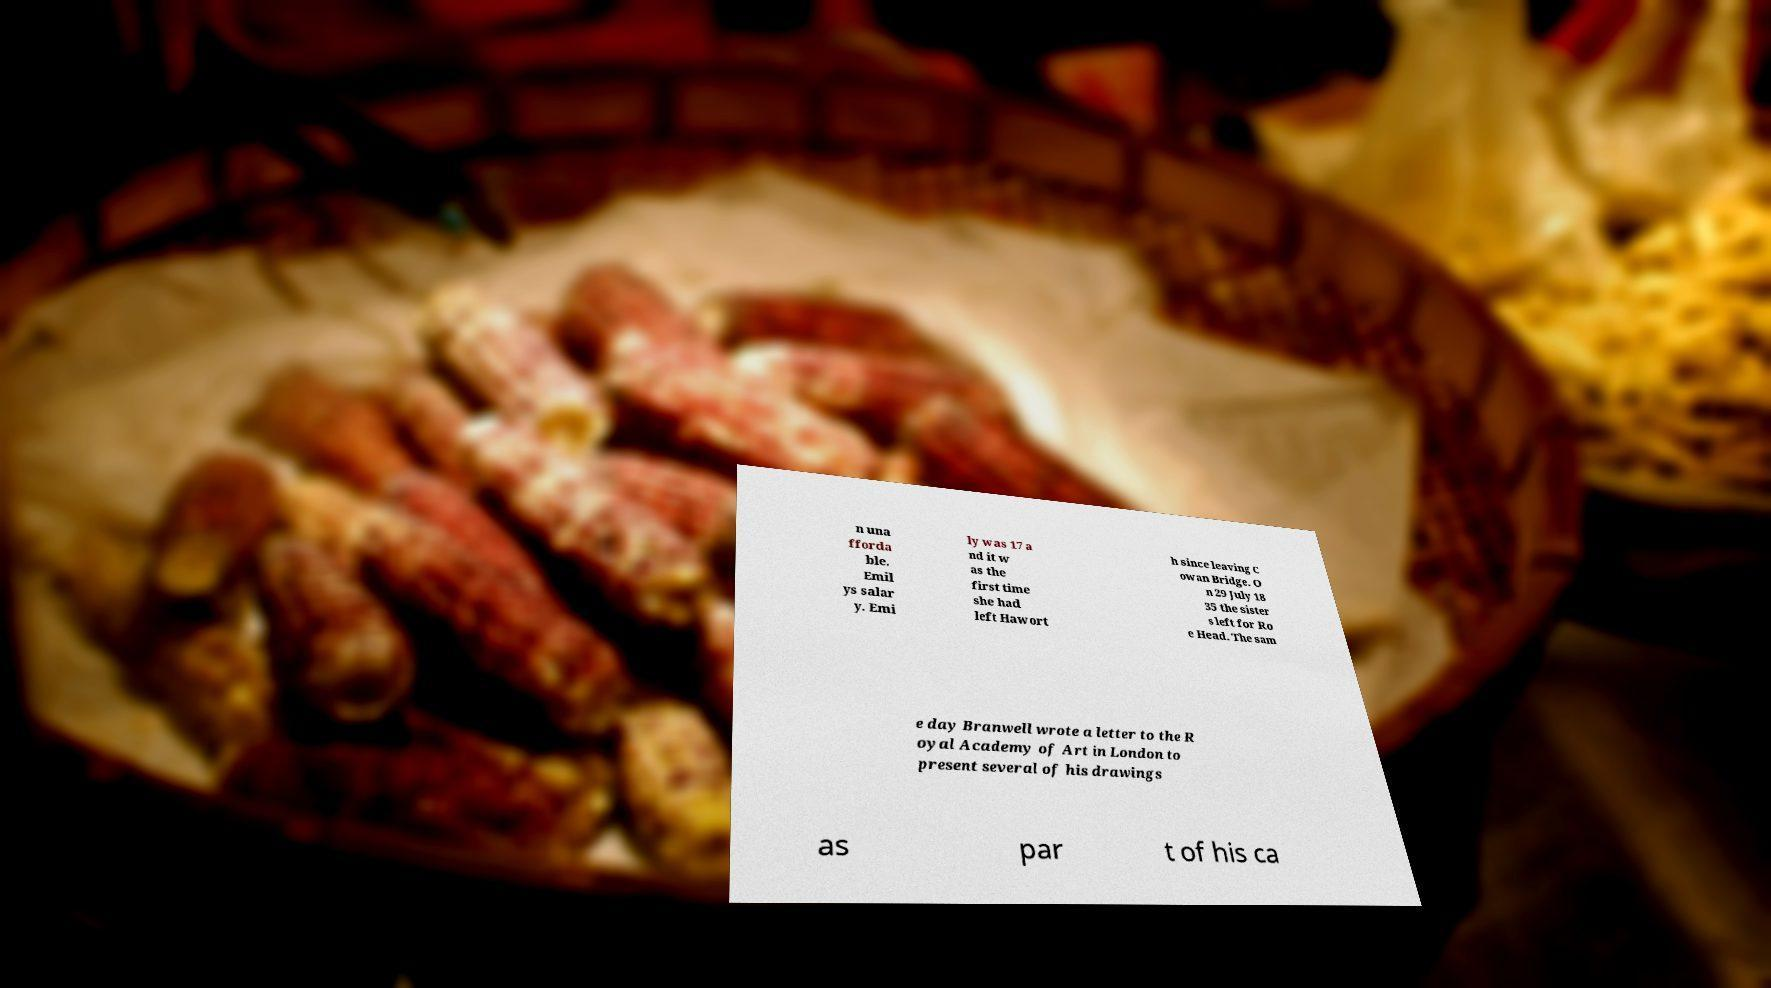There's text embedded in this image that I need extracted. Can you transcribe it verbatim? n una fforda ble. Emil ys salar y. Emi ly was 17 a nd it w as the first time she had left Hawort h since leaving C owan Bridge. O n 29 July 18 35 the sister s left for Ro e Head. The sam e day Branwell wrote a letter to the R oyal Academy of Art in London to present several of his drawings as par t of his ca 